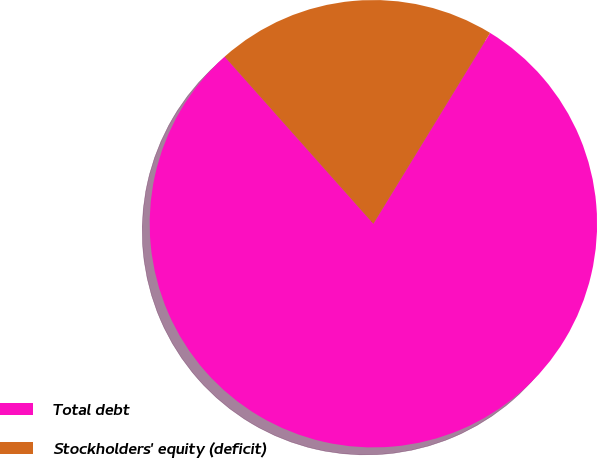Convert chart to OTSL. <chart><loc_0><loc_0><loc_500><loc_500><pie_chart><fcel>Total debt<fcel>Stockholders' equity (deficit)<nl><fcel>79.69%<fcel>20.31%<nl></chart> 